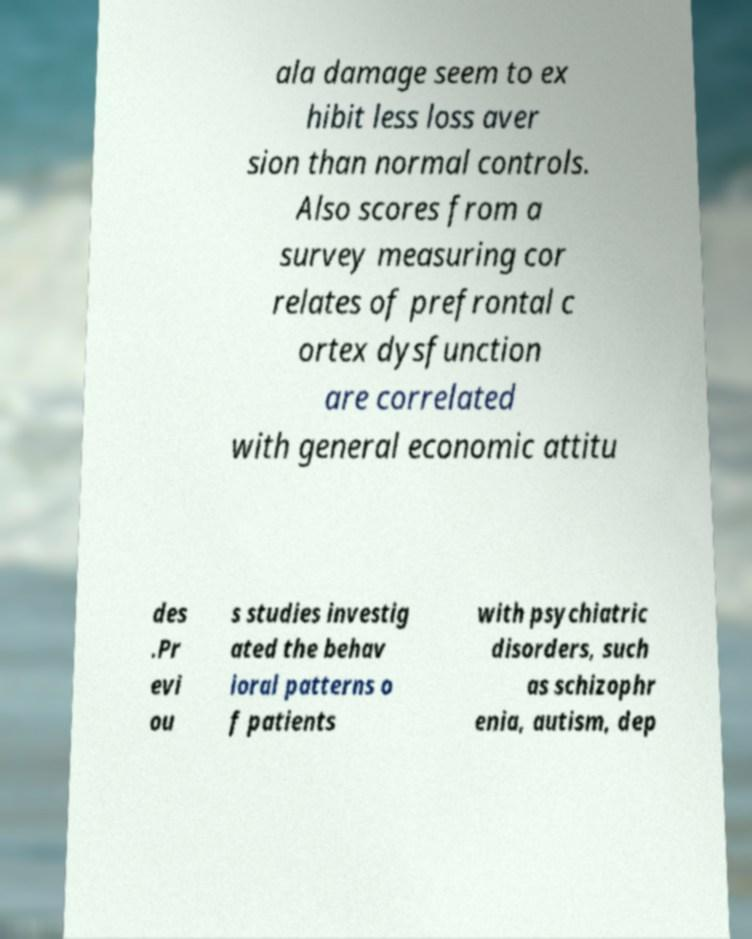There's text embedded in this image that I need extracted. Can you transcribe it verbatim? ala damage seem to ex hibit less loss aver sion than normal controls. Also scores from a survey measuring cor relates of prefrontal c ortex dysfunction are correlated with general economic attitu des .Pr evi ou s studies investig ated the behav ioral patterns o f patients with psychiatric disorders, such as schizophr enia, autism, dep 